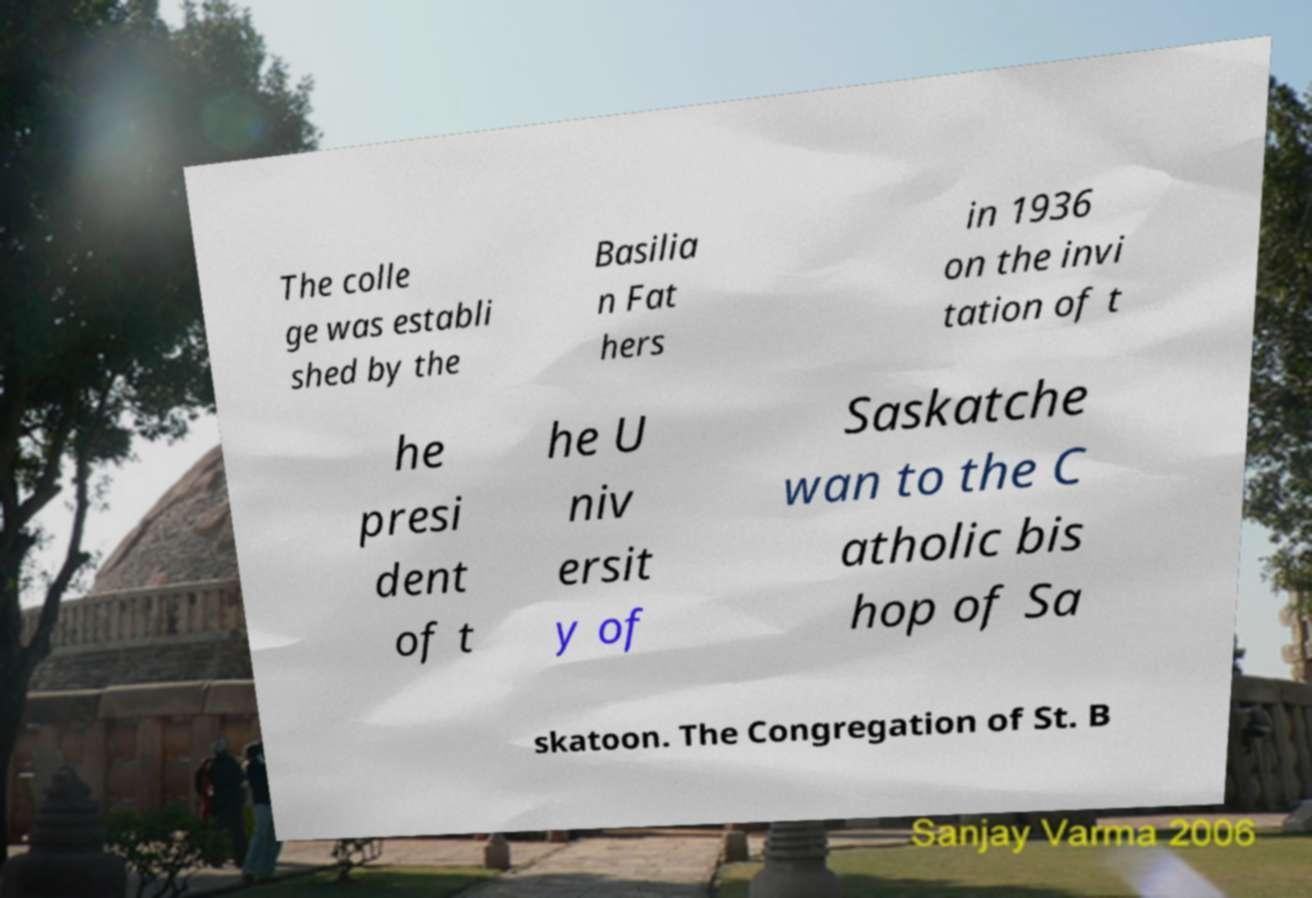Could you extract and type out the text from this image? The colle ge was establi shed by the Basilia n Fat hers in 1936 on the invi tation of t he presi dent of t he U niv ersit y of Saskatche wan to the C atholic bis hop of Sa skatoon. The Congregation of St. B 